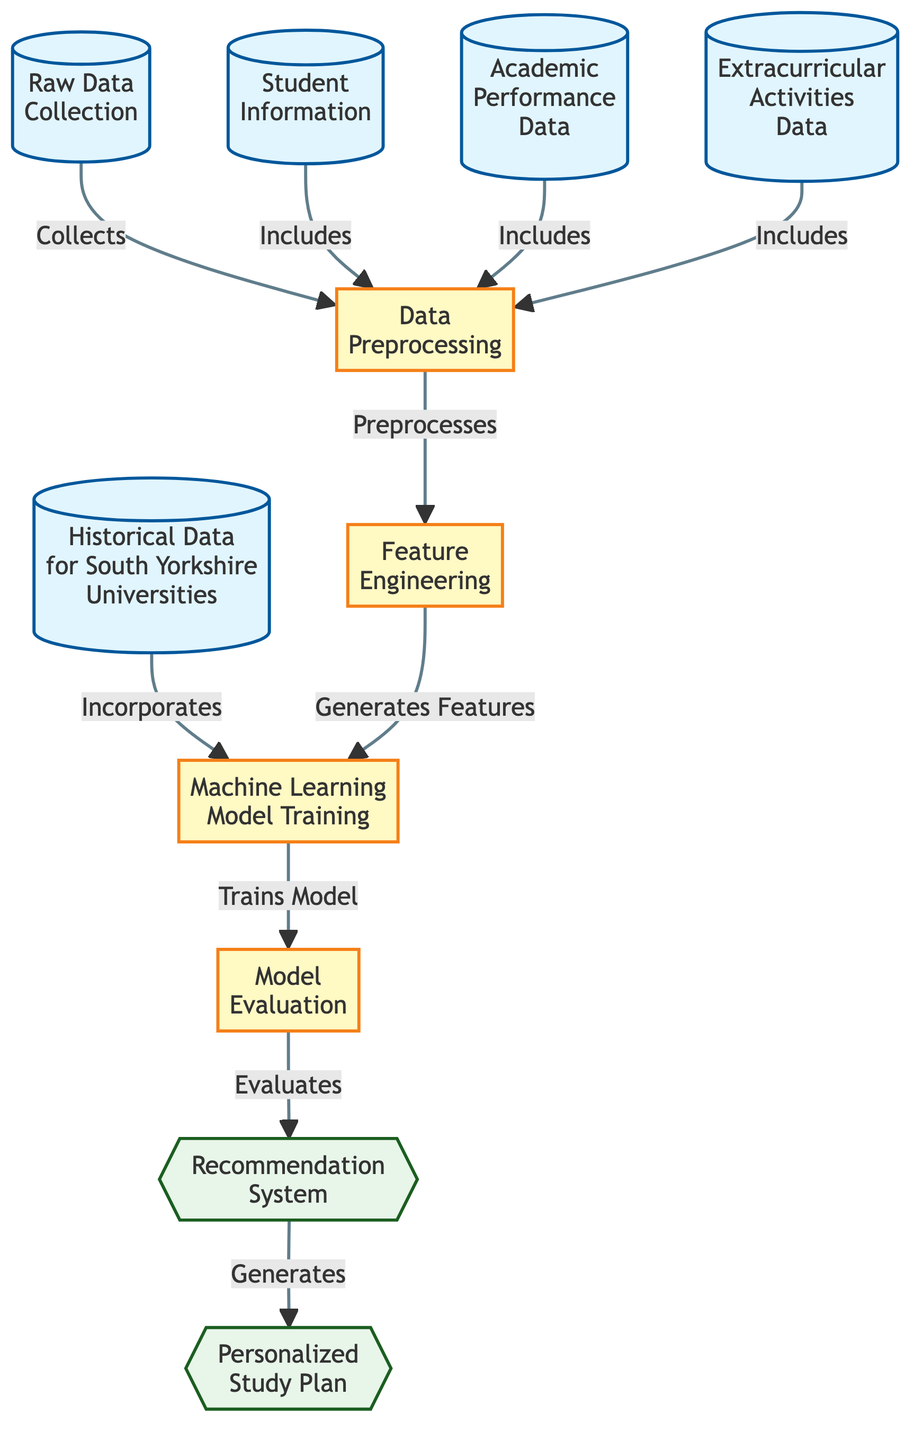What are the three types of data collected in the initial steps? The diagram shows three types of raw data collection: Student Information, Academic Performance Data, and Extracurricular Activities Data. They are all indicated as nodes connected to the Data Preprocessing step.
Answer: Student Information, Academic Performance Data, Extracurricular Activities Data What does the Data Preprocessing step lead to? Data Preprocessing is connected to Feature Engineering, indicating it leads directly to this step. This means the data processed will be used for engineering features.
Answer: Feature Engineering How many steps are involved in the processing sequence before recommendations are generated? The diagram includes five processing steps: Data Preprocessing, Feature Engineering, Machine Learning Model Training, Model Evaluation, and the Recommendation System. Counting these gives a total of five steps.
Answer: Five What is the output of the Machine Learning Model Training? The output from the Machine Learning Model Training step is connected to the Model Evaluation step, indicating that the output leads to evaluating the model.
Answer: Model Evaluation What is generated at the end of the process? At the end of the process, there are two outputs: the Recommendation System and the Personalized Study Plan. Both are final outputs from the flowchart.
Answer: Recommendation System, Personalized Study Plan What step incorporates historical data for South Yorkshire universities? In the diagram, the step that incorporates historical data for South Yorkshire universities is labeled as Machine Learning Model Training. It shows that this data feeds into training the model.
Answer: Machine Learning Model Training Describe the flow of information from raw data collection to the personalized study plan. The flow starts from Raw Data Collection, which includes Student Information, Academic Performance Data, and Extracurricular Activities Data, leading to Data Preprocessing. This is followed by Feature Engineering, which generates features necessary for Machine Learning Model Training. After the model is trained, it goes through Model Evaluation which ultimately generates the Recommendation System and then the Personalized Study Plan.
Answer: Raw Data Collection to Personalized Study Plan What role does Feature Engineering play in the diagram? Feature Engineering generates features that are used in the Machine Learning Model Training. This indicates it is a crucial intermediary step, transforming preprocessed data into a usable format for modeling.
Answer: Generates Features 